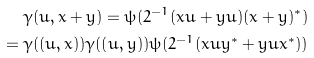Convert formula to latex. <formula><loc_0><loc_0><loc_500><loc_500>\gamma ( u , x + y ) = \psi ( 2 ^ { - 1 } ( x u + y u ) ( x + y ) ^ { * } ) \\ = \gamma ( ( u , x ) ) \gamma ( ( u , y ) ) \psi ( 2 ^ { - 1 } ( x u y ^ { * } + y u x ^ { * } ) ) \\</formula> 